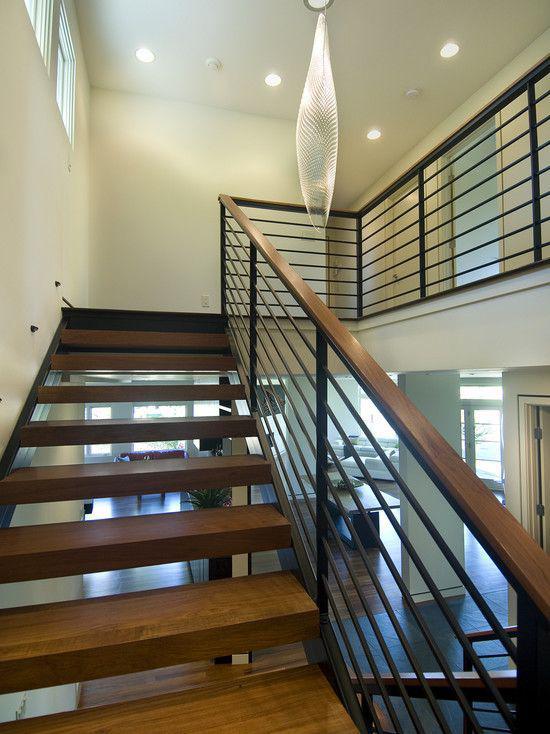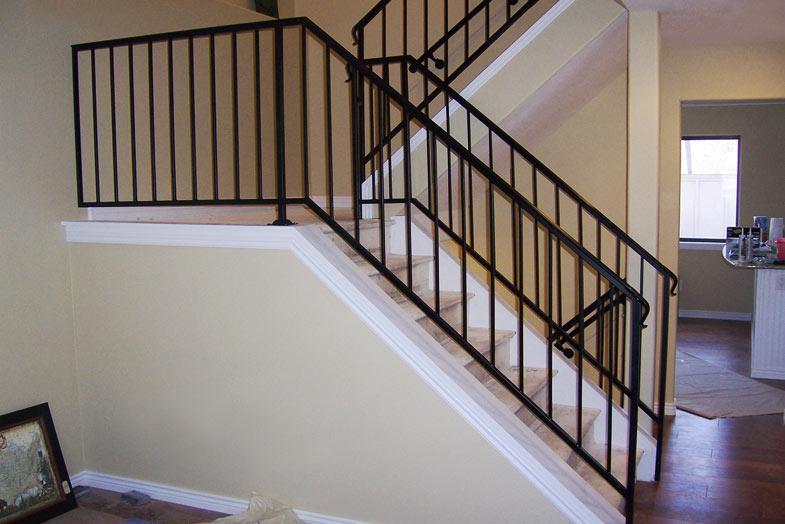The first image is the image on the left, the second image is the image on the right. For the images displayed, is the sentence "One set of stairs heads in just one direction." factually correct? Answer yes or no. No. 